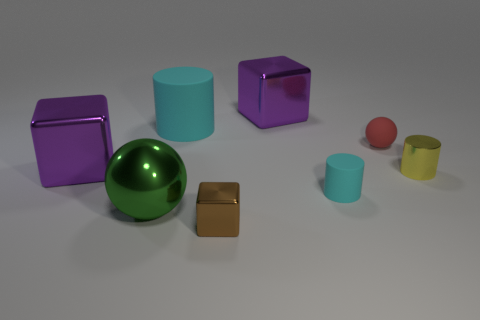How many objects are in the image and can you describe their shapes and colors? There are seven objects in the image. Starting from the left, there's a purple cube, a large teal cylinder, and a purple cube with its corner facing up. In the center, there's a shiny green sphere. To the right, there's a small brown cube, and two cylinders, with one smaller yellow cylinder inside a larger transparent cylinder. Lastly, there's a small red sphere. 